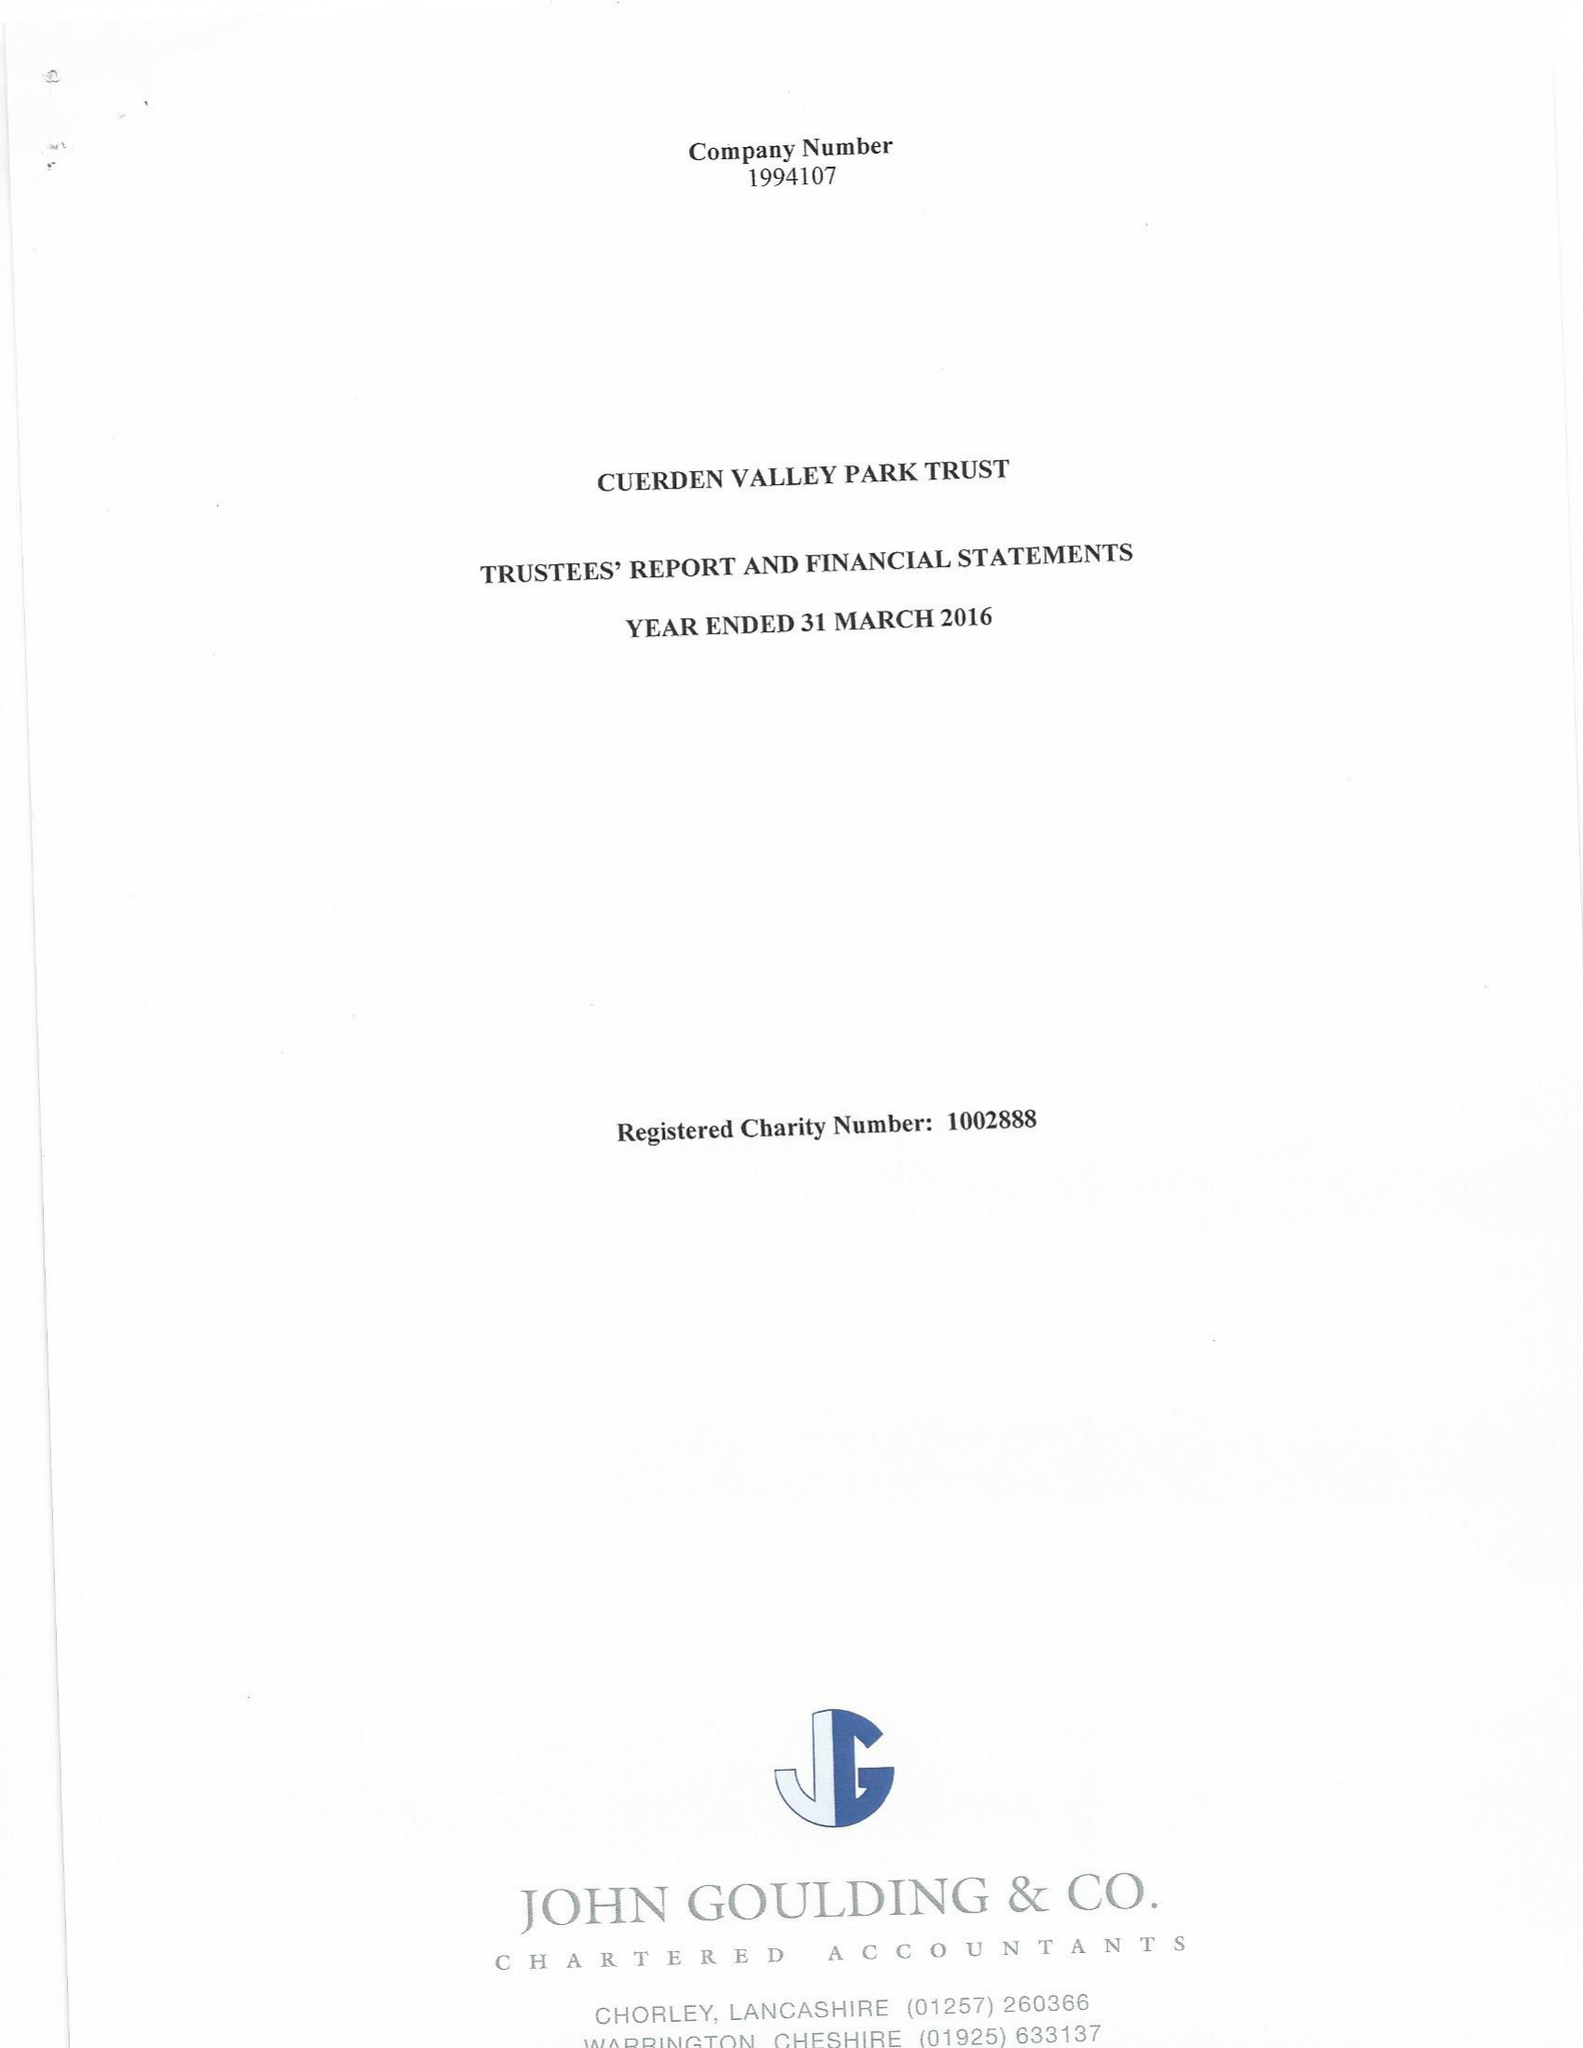What is the value for the charity_name?
Answer the question using a single word or phrase. Cuerden Valley Park Trust 